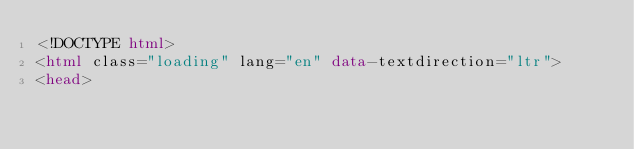<code> <loc_0><loc_0><loc_500><loc_500><_HTML_><!DOCTYPE html>
<html class="loading" lang="en" data-textdirection="ltr">
<head></code> 